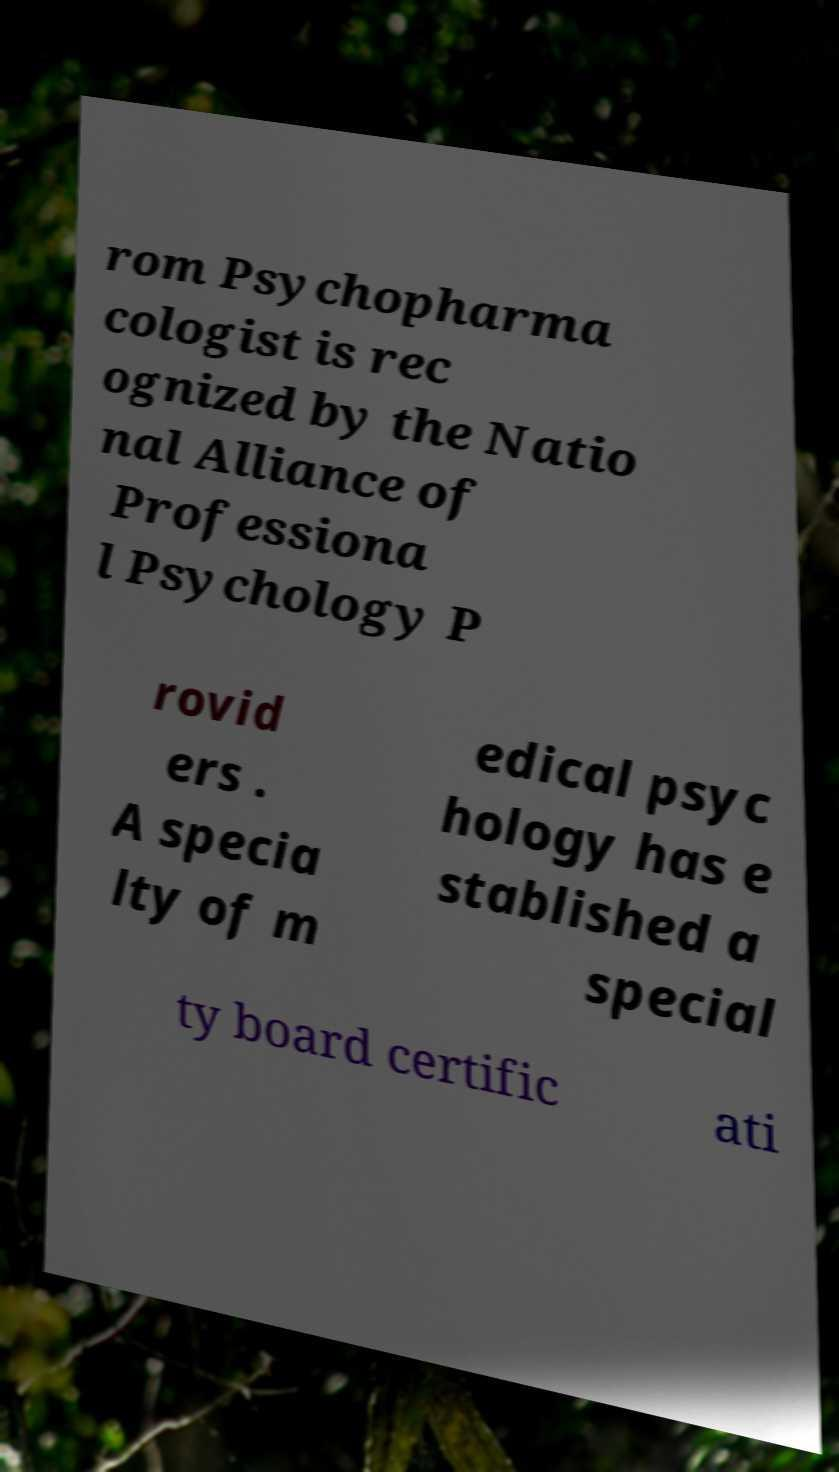What messages or text are displayed in this image? I need them in a readable, typed format. rom Psychopharma cologist is rec ognized by the Natio nal Alliance of Professiona l Psychology P rovid ers . A specia lty of m edical psyc hology has e stablished a special ty board certific ati 